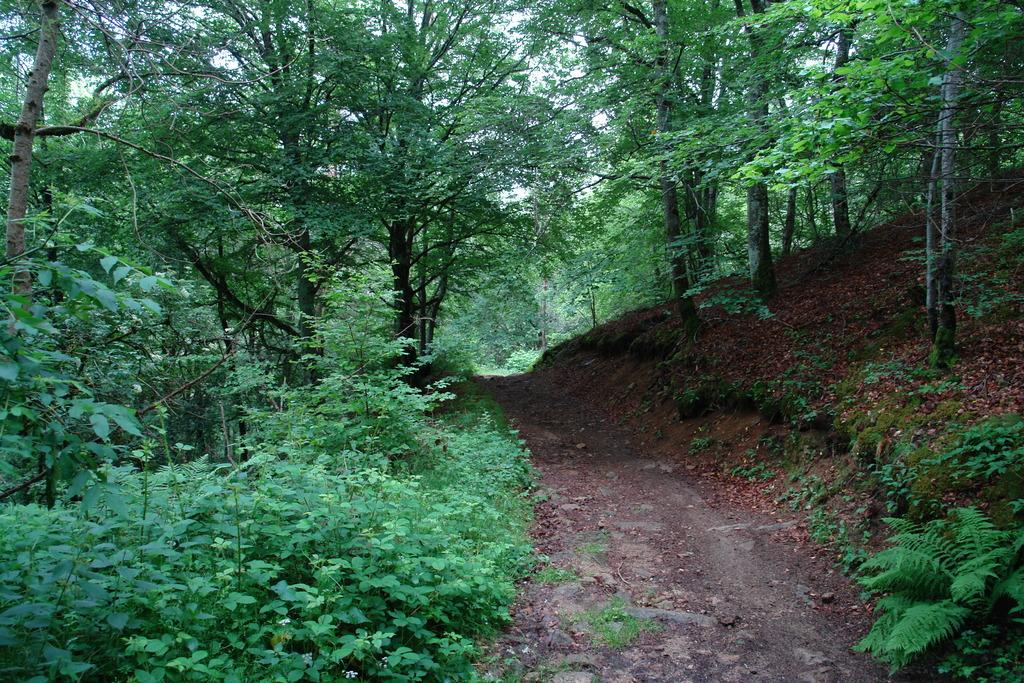What type of natural feature is located on the right side of the image? There is a mountain on the right side of the image. What type of vegetation can be seen in the image? There are trees and plants in the image. What type of ground cover is present on the left side of the image? There is grass on the left side of the image. Are there any trees on the left side of the image? Yes, there are trees on the left side of the image. What type of advice does the grandfather give to the duck in the image? There is no grandfather or duck present in the image, so no such interaction can be observed. 